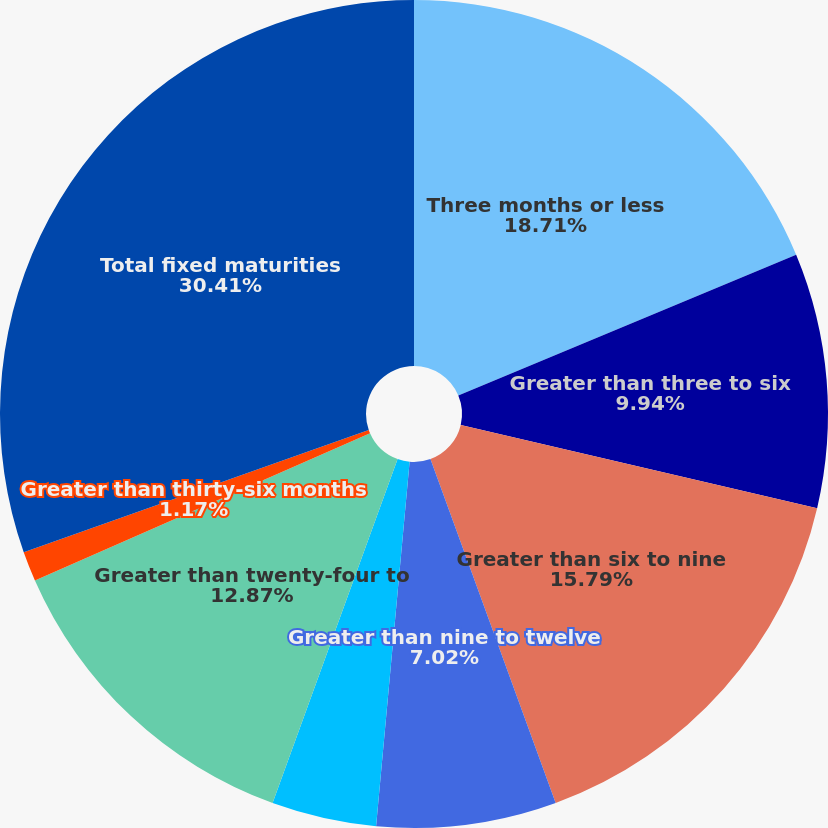Convert chart to OTSL. <chart><loc_0><loc_0><loc_500><loc_500><pie_chart><fcel>Three months or less<fcel>Greater than three to six<fcel>Greater than six to nine<fcel>Greater than nine to twelve<fcel>Greater than twelve to<fcel>Greater than twenty-four to<fcel>Greater than thirty-six months<fcel>Total fixed maturities<nl><fcel>18.72%<fcel>9.94%<fcel>15.79%<fcel>7.02%<fcel>4.09%<fcel>12.87%<fcel>1.17%<fcel>30.42%<nl></chart> 